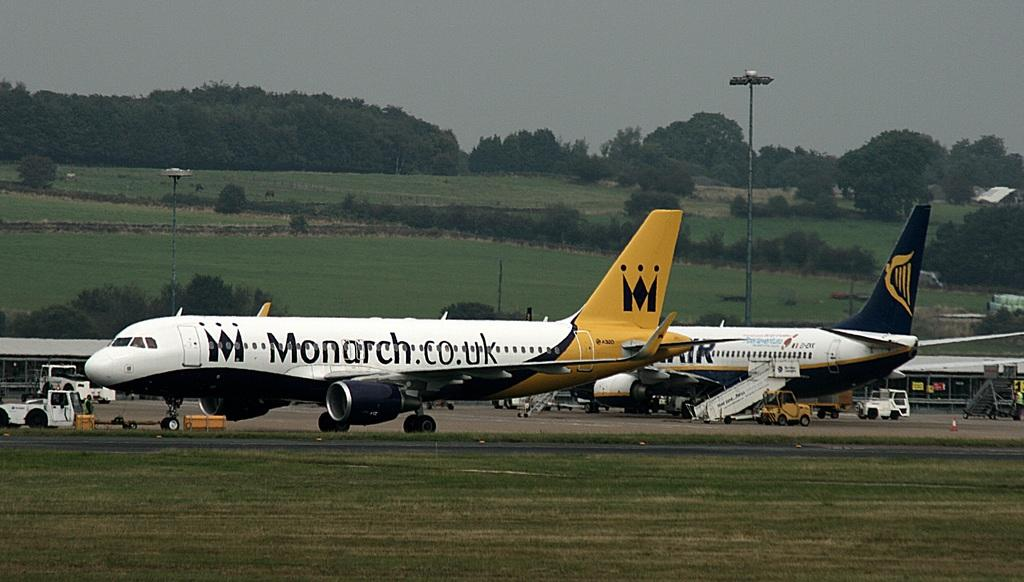<image>
Relay a brief, clear account of the picture shown. Black, white and gold airplanes from Monarch airline are parked on the runway. 